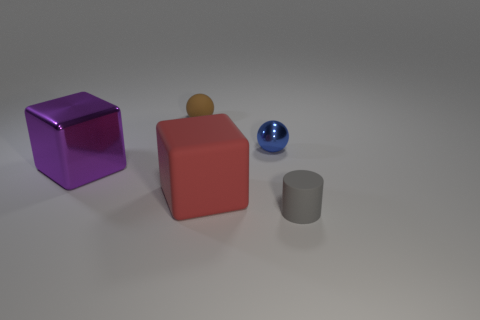Add 5 yellow spheres. How many objects exist? 10 Subtract all green balls. How many red blocks are left? 1 Subtract 0 cyan cubes. How many objects are left? 5 Subtract all cylinders. How many objects are left? 4 Subtract all green balls. Subtract all purple cylinders. How many balls are left? 2 Subtract all small rubber spheres. Subtract all cubes. How many objects are left? 2 Add 2 big purple metallic things. How many big purple metallic things are left? 3 Add 2 big blue objects. How many big blue objects exist? 2 